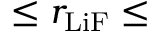Convert formula to latex. <formula><loc_0><loc_0><loc_500><loc_500>\leq r _ { L i F } \leq</formula> 